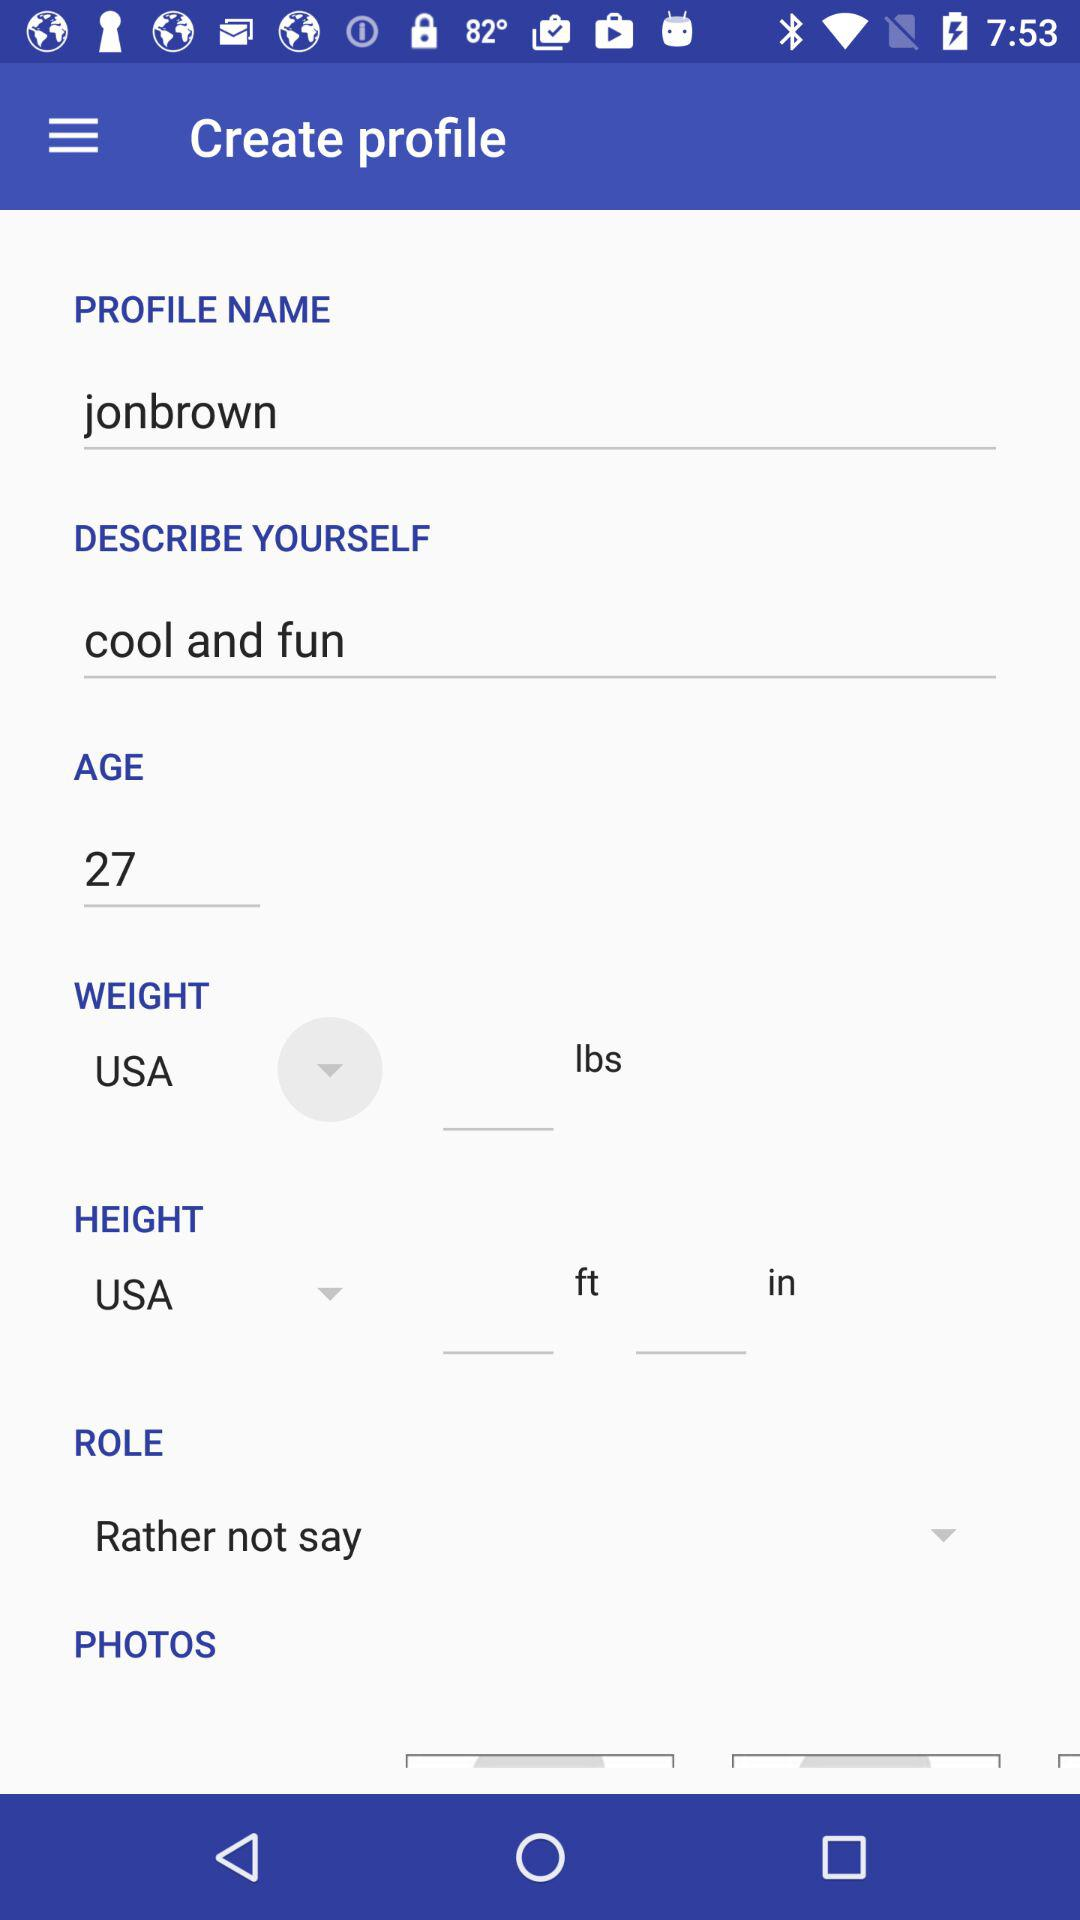What is the age of the user? The age of the user is 27. 